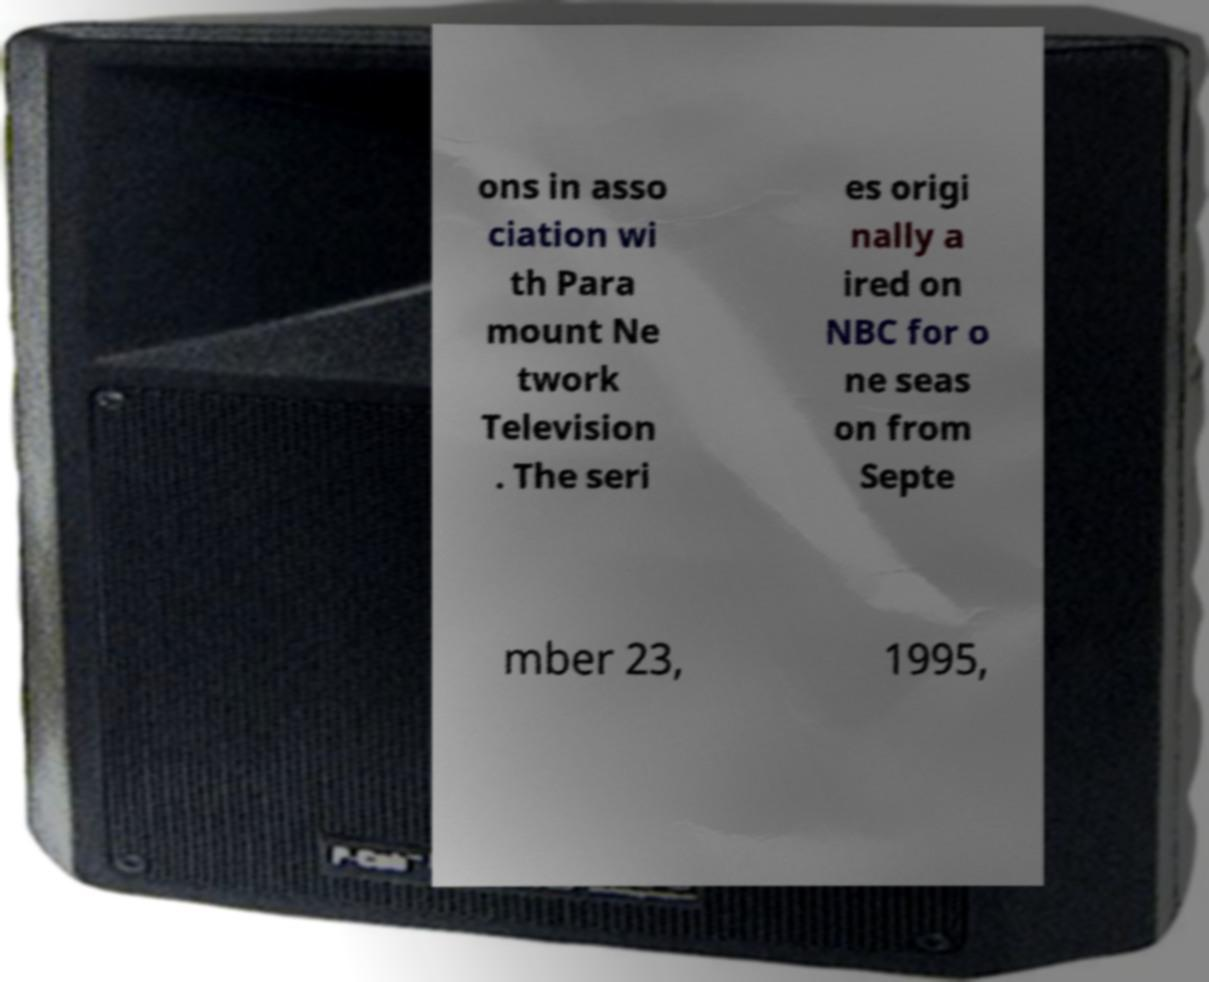I need the written content from this picture converted into text. Can you do that? ons in asso ciation wi th Para mount Ne twork Television . The seri es origi nally a ired on NBC for o ne seas on from Septe mber 23, 1995, 